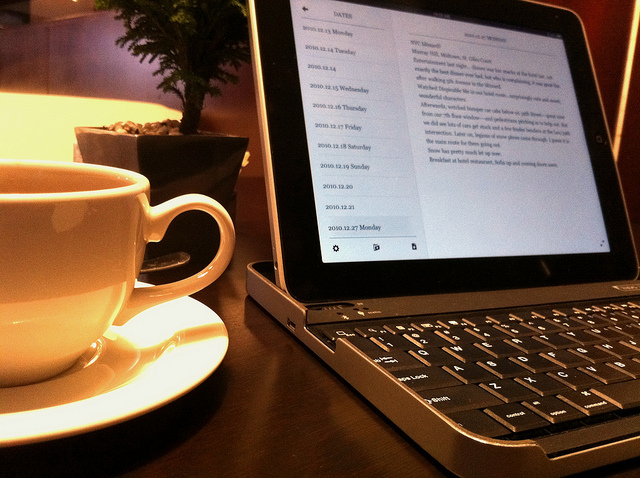Read all the text in this image. O C 